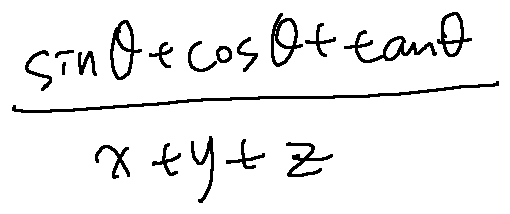Convert formula to latex. <formula><loc_0><loc_0><loc_500><loc_500>\frac { \sin \theta + \cos \theta + \tan \theta } { x + y + z }</formula> 